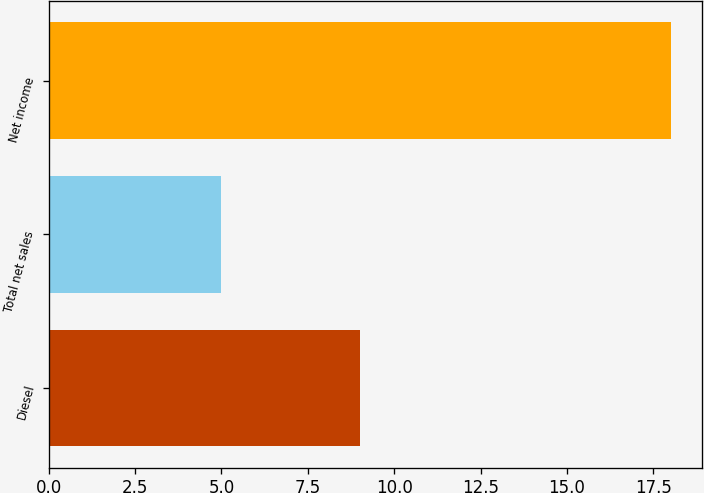<chart> <loc_0><loc_0><loc_500><loc_500><bar_chart><fcel>Diesel<fcel>Total net sales<fcel>Net income<nl><fcel>9<fcel>5<fcel>18<nl></chart> 